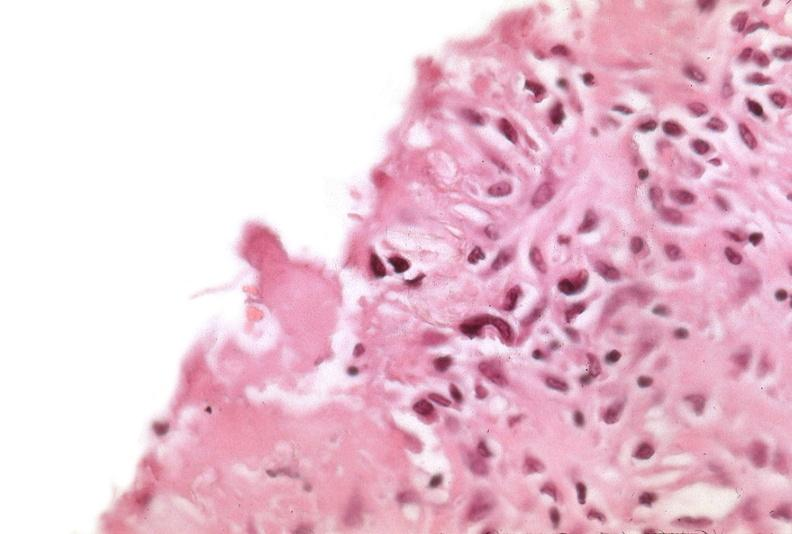what does this image show?
Answer the question using a single word or phrase. Pleura 